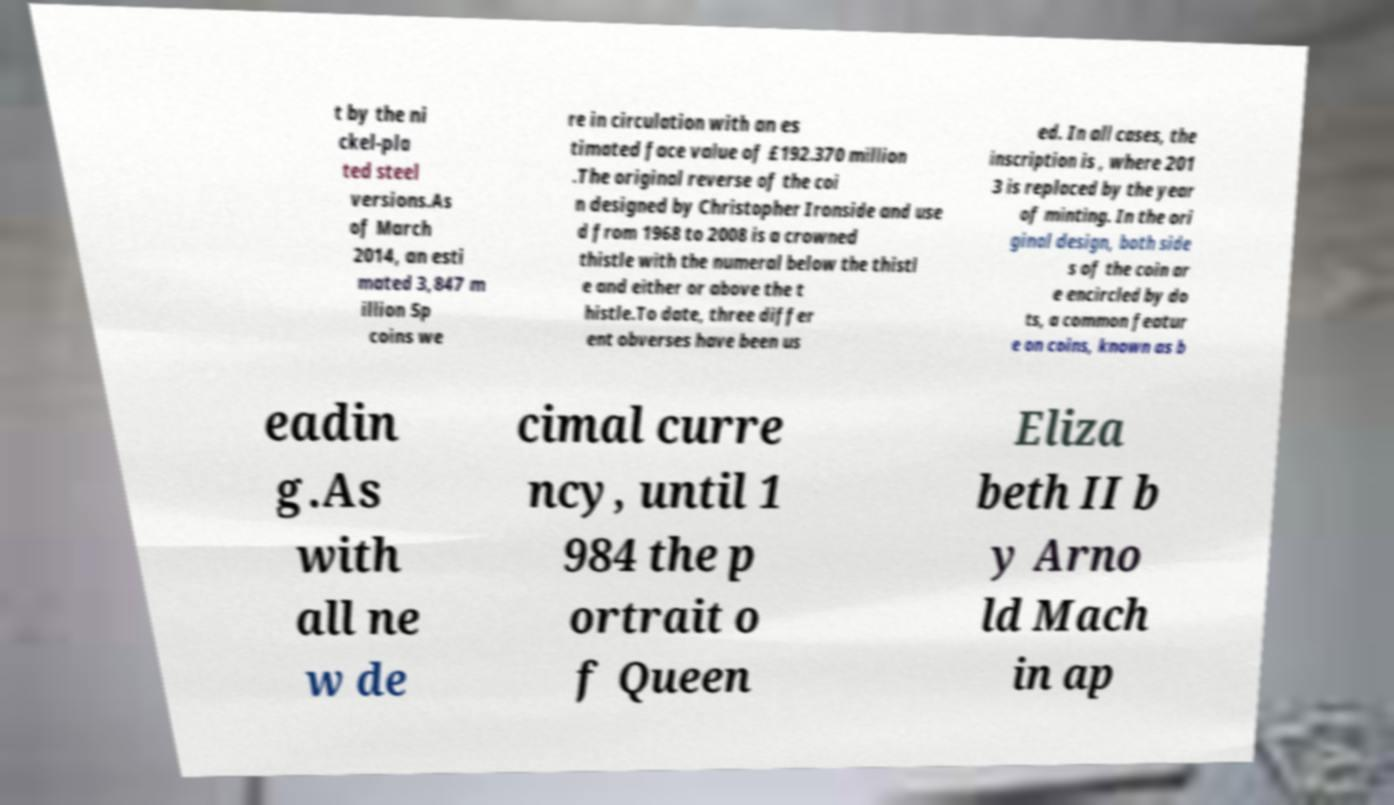Could you assist in decoding the text presented in this image and type it out clearly? t by the ni ckel-pla ted steel versions.As of March 2014, an esti mated 3,847 m illion 5p coins we re in circulation with an es timated face value of £192.370 million .The original reverse of the coi n designed by Christopher Ironside and use d from 1968 to 2008 is a crowned thistle with the numeral below the thistl e and either or above the t histle.To date, three differ ent obverses have been us ed. In all cases, the inscription is , where 201 3 is replaced by the year of minting. In the ori ginal design, both side s of the coin ar e encircled by do ts, a common featur e on coins, known as b eadin g.As with all ne w de cimal curre ncy, until 1 984 the p ortrait o f Queen Eliza beth II b y Arno ld Mach in ap 